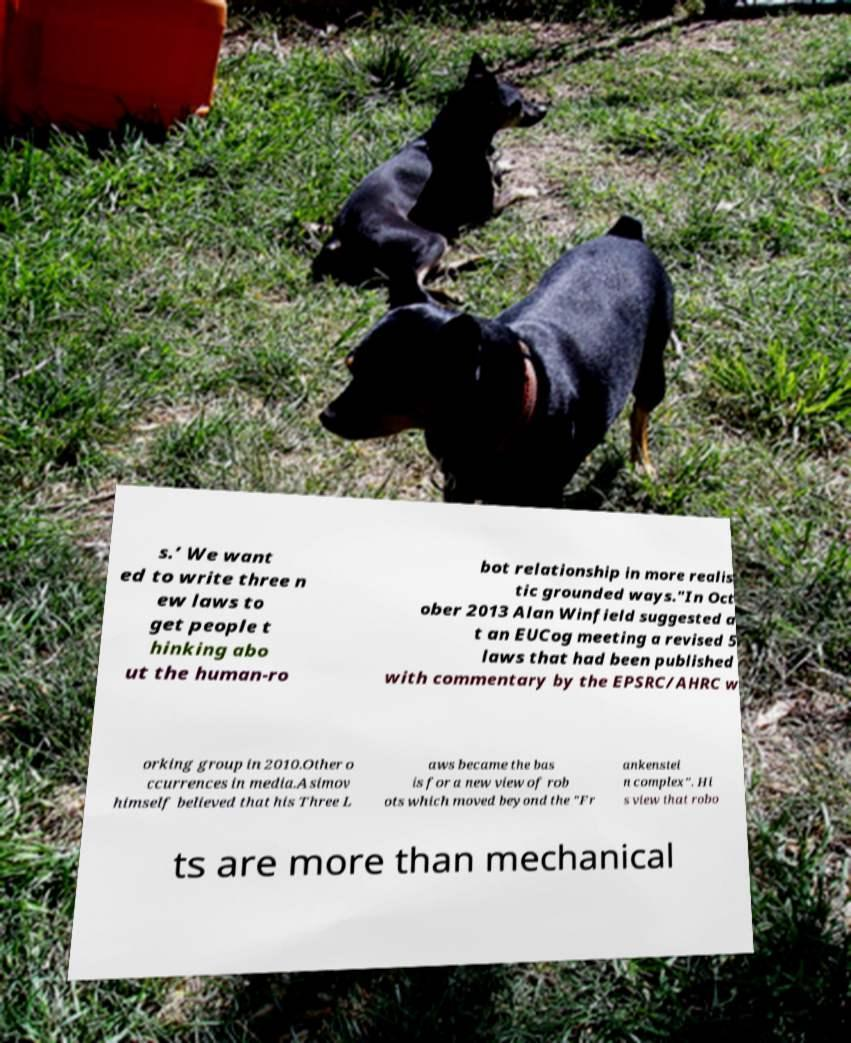There's text embedded in this image that I need extracted. Can you transcribe it verbatim? s.’ We want ed to write three n ew laws to get people t hinking abo ut the human-ro bot relationship in more realis tic grounded ways."In Oct ober 2013 Alan Winfield suggested a t an EUCog meeting a revised 5 laws that had been published with commentary by the EPSRC/AHRC w orking group in 2010.Other o ccurrences in media.Asimov himself believed that his Three L aws became the bas is for a new view of rob ots which moved beyond the "Fr ankenstei n complex". Hi s view that robo ts are more than mechanical 